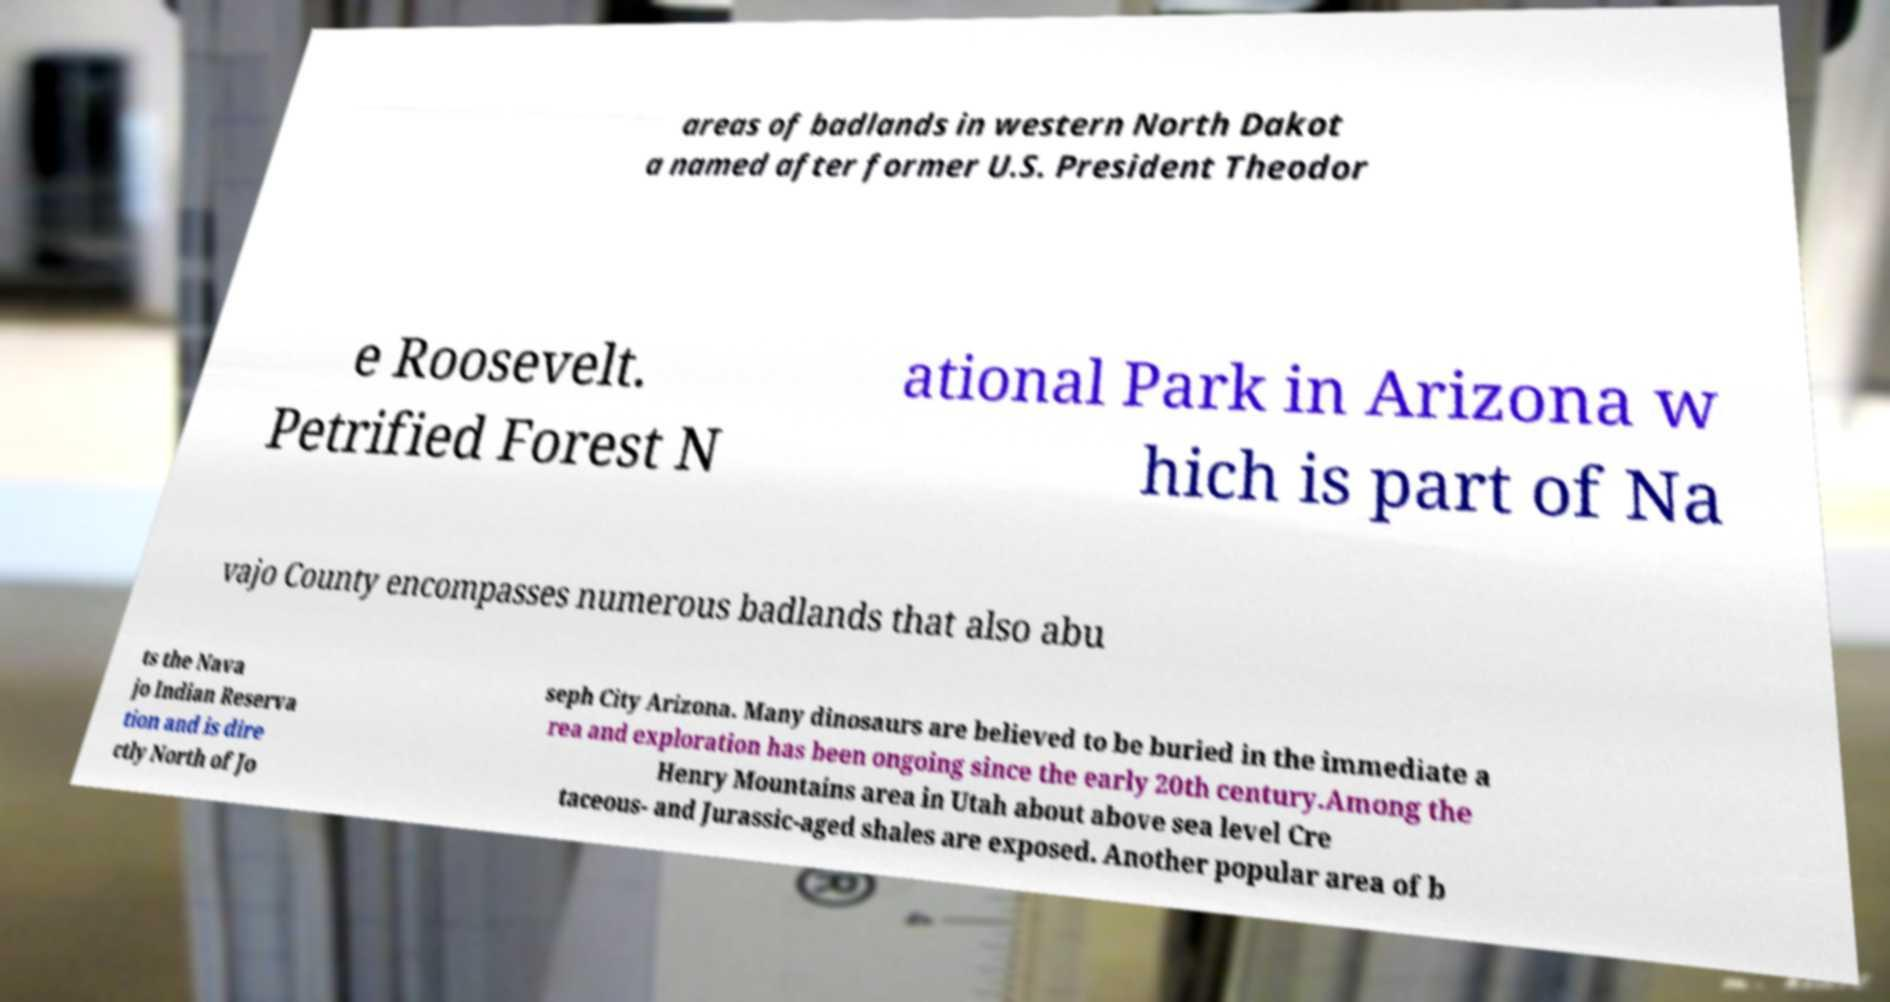Could you assist in decoding the text presented in this image and type it out clearly? areas of badlands in western North Dakot a named after former U.S. President Theodor e Roosevelt. Petrified Forest N ational Park in Arizona w hich is part of Na vajo County encompasses numerous badlands that also abu ts the Nava jo Indian Reserva tion and is dire ctly North of Jo seph City Arizona. Many dinosaurs are believed to be buried in the immediate a rea and exploration has been ongoing since the early 20th century.Among the Henry Mountains area in Utah about above sea level Cre taceous- and Jurassic-aged shales are exposed. Another popular area of b 